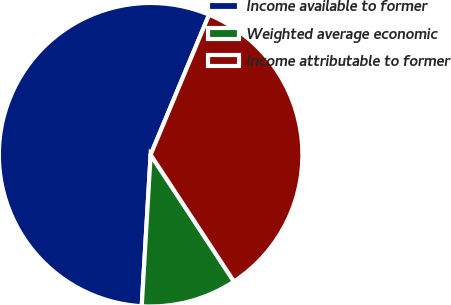Convert chart to OTSL. <chart><loc_0><loc_0><loc_500><loc_500><pie_chart><fcel>Income available to former<fcel>Weighted average economic<fcel>Income attributable to former<nl><fcel>55.36%<fcel>10.19%<fcel>34.45%<nl></chart> 